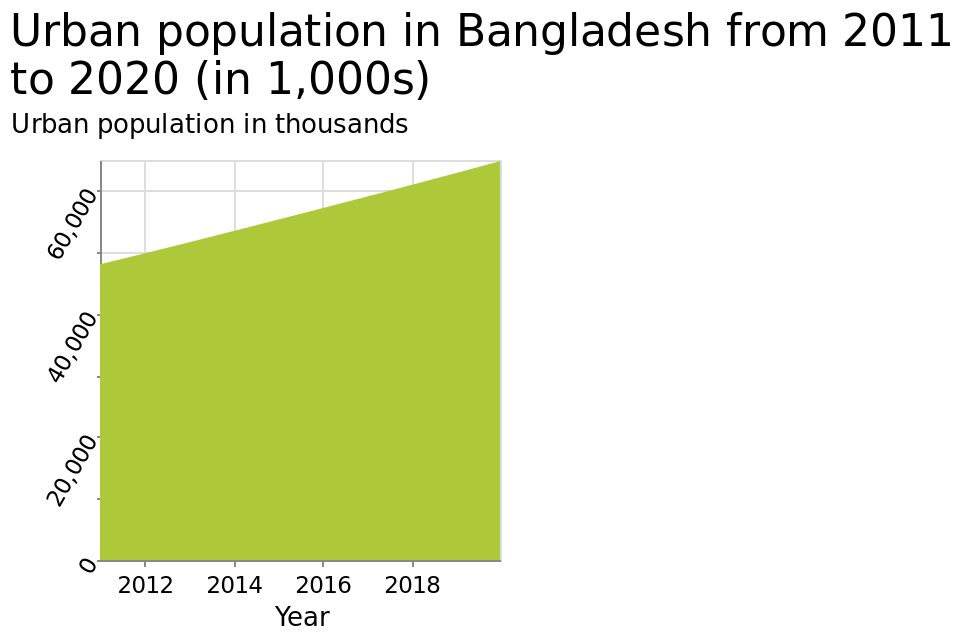<image>
How much has the urban population of Bangladesh increased since 2011? The urban population of Bangladesh has increased by 15000 since 2011. 